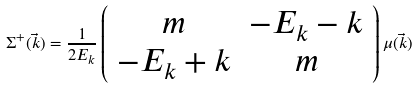Convert formula to latex. <formula><loc_0><loc_0><loc_500><loc_500>\Sigma ^ { + } ( \vec { k } ) = \frac { 1 } { 2 E _ { k } } \left ( \begin{array} { c c } { m } & { { - E _ { k } - k } } \\ { { - E _ { k } + k } } & { m } \end{array} \right ) \mu ( \vec { k } )</formula> 